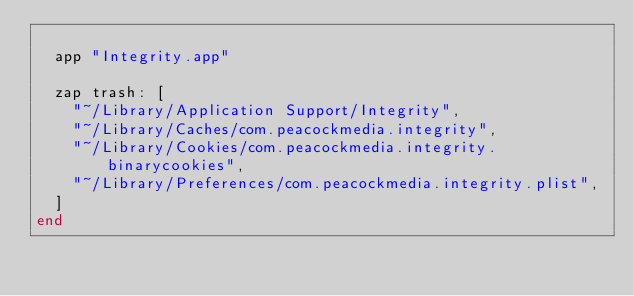Convert code to text. <code><loc_0><loc_0><loc_500><loc_500><_Ruby_>
  app "Integrity.app"

  zap trash: [
    "~/Library/Application Support/Integrity",
    "~/Library/Caches/com.peacockmedia.integrity",
    "~/Library/Cookies/com.peacockmedia.integrity.binarycookies",
    "~/Library/Preferences/com.peacockmedia.integrity.plist",
  ]
end
</code> 